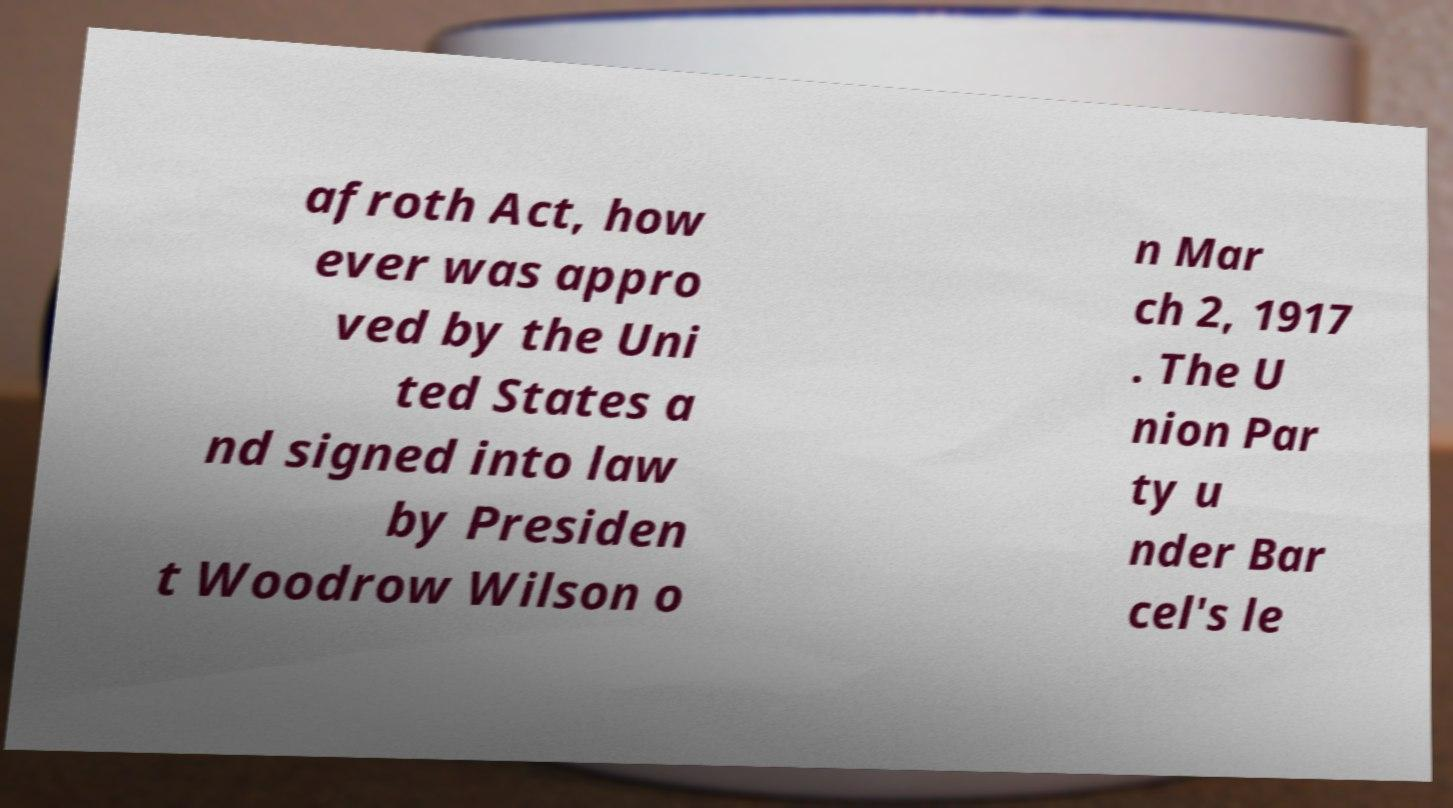For documentation purposes, I need the text within this image transcribed. Could you provide that? afroth Act, how ever was appro ved by the Uni ted States a nd signed into law by Presiden t Woodrow Wilson o n Mar ch 2, 1917 . The U nion Par ty u nder Bar cel's le 